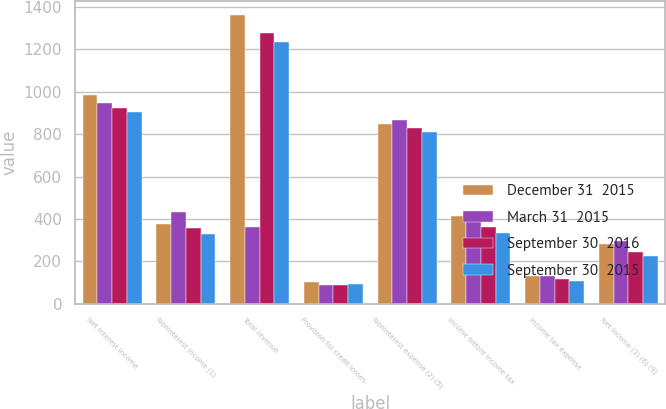Convert chart to OTSL. <chart><loc_0><loc_0><loc_500><loc_500><stacked_bar_chart><ecel><fcel>Net interest income<fcel>Noninterest income (1)<fcel>Total revenue<fcel>Provision for credit losses<fcel>Noninterest expense (2) (5)<fcel>Income before income tax<fcel>Income tax expense<fcel>Net income (3) (6) (9)<nl><fcel>December 31  2015<fcel>986<fcel>377<fcel>1363<fcel>102<fcel>847<fcel>414<fcel>132<fcel>282<nl><fcel>March 31  2015<fcel>945<fcel>435<fcel>361<fcel>86<fcel>867<fcel>427<fcel>130<fcel>297<nl><fcel>September 30  2016<fcel>923<fcel>355<fcel>1278<fcel>90<fcel>827<fcel>361<fcel>118<fcel>243<nl><fcel>September 30  2015<fcel>904<fcel>330<fcel>1234<fcel>91<fcel>811<fcel>332<fcel>109<fcel>223<nl></chart> 